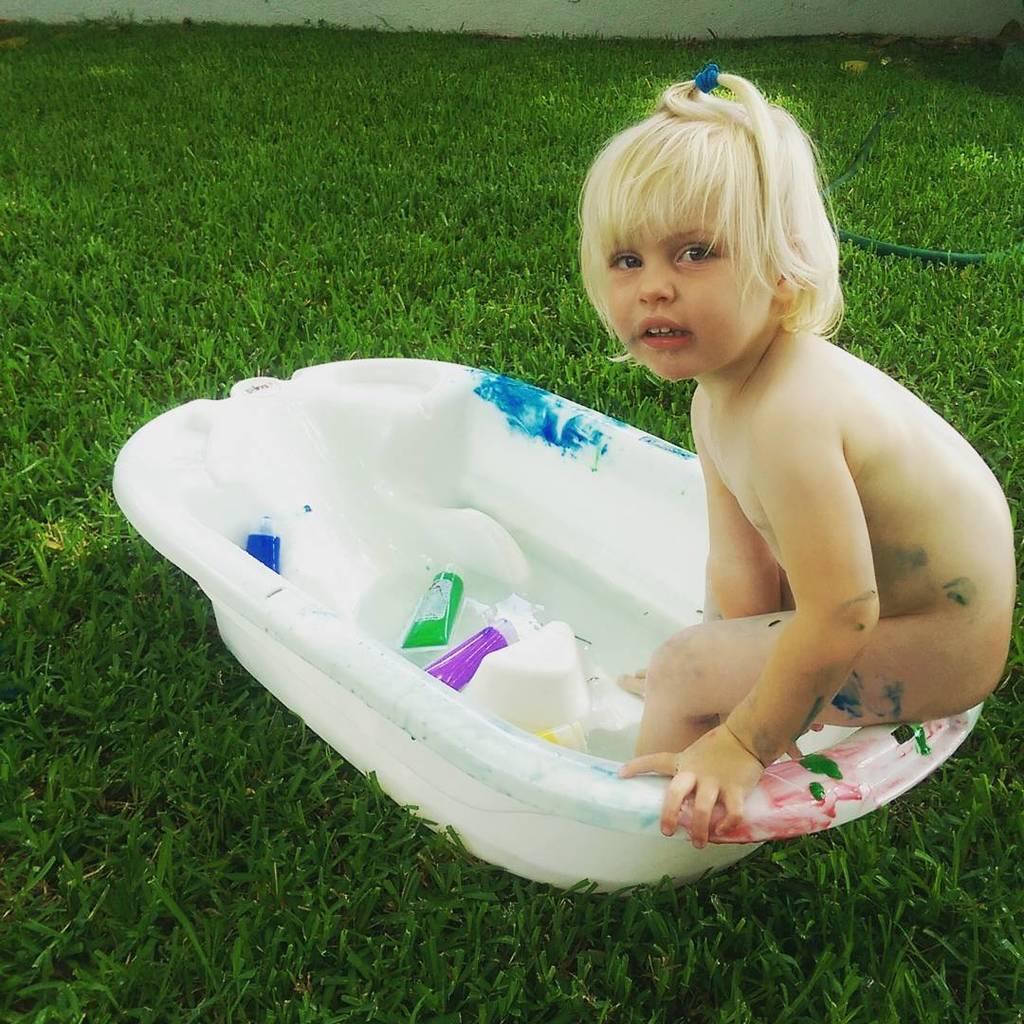Could you give a brief overview of what you see in this image? In this image we can see one girl is sitting in a white color tub. The tub is on the grassy land and we can see one pipe also. In the tub two bottles are there. 